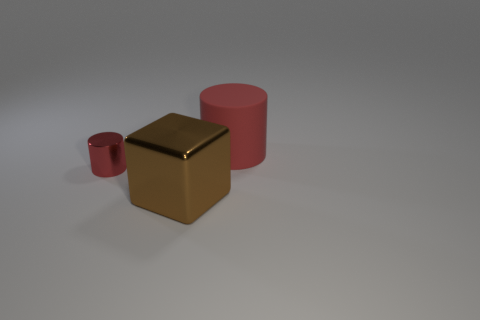Add 3 large rubber things. How many objects exist? 6 Subtract all cylinders. How many objects are left? 1 Add 1 big red rubber cylinders. How many big red rubber cylinders are left? 2 Add 3 large red things. How many large red things exist? 4 Subtract 0 green balls. How many objects are left? 3 Subtract all red matte cylinders. Subtract all large brown objects. How many objects are left? 1 